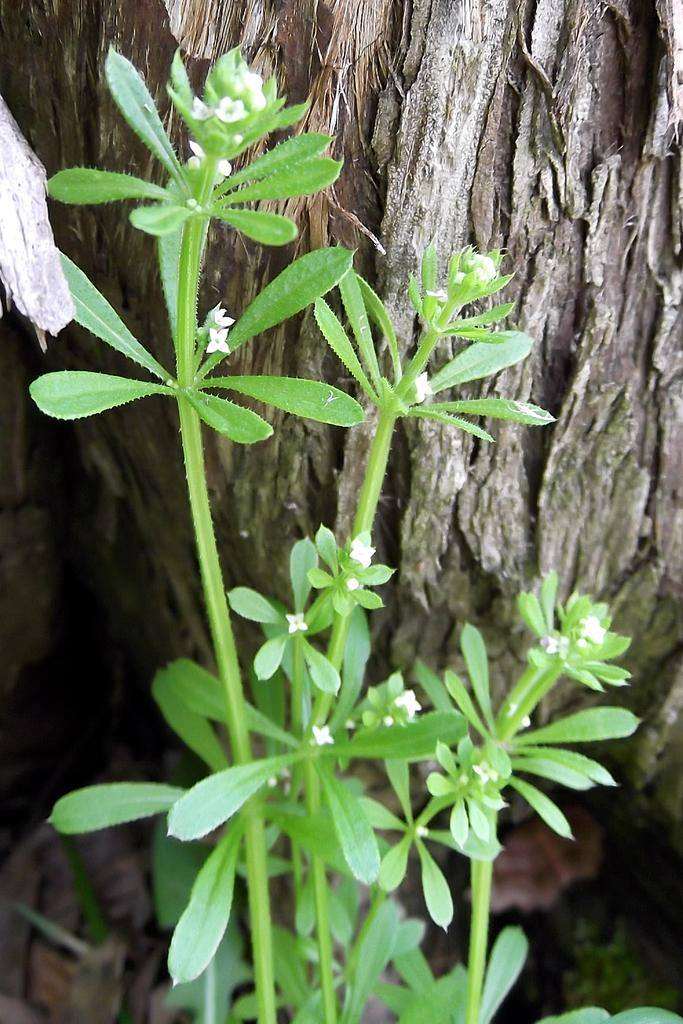What type of plant is in the image? There is a white-colored small flowers plant in the image. Where is the plant located in the image? The plant is in the front of the image. What else can be seen in the image besides the plant? There is a tree trunk visible in the image. What type of grape is growing on the tree trunk in the image? There are no grapes present in the image; it features a white-colored small flowers plant and a tree trunk. What nation is represented by the flag in the image? There is no flag present in the image. 